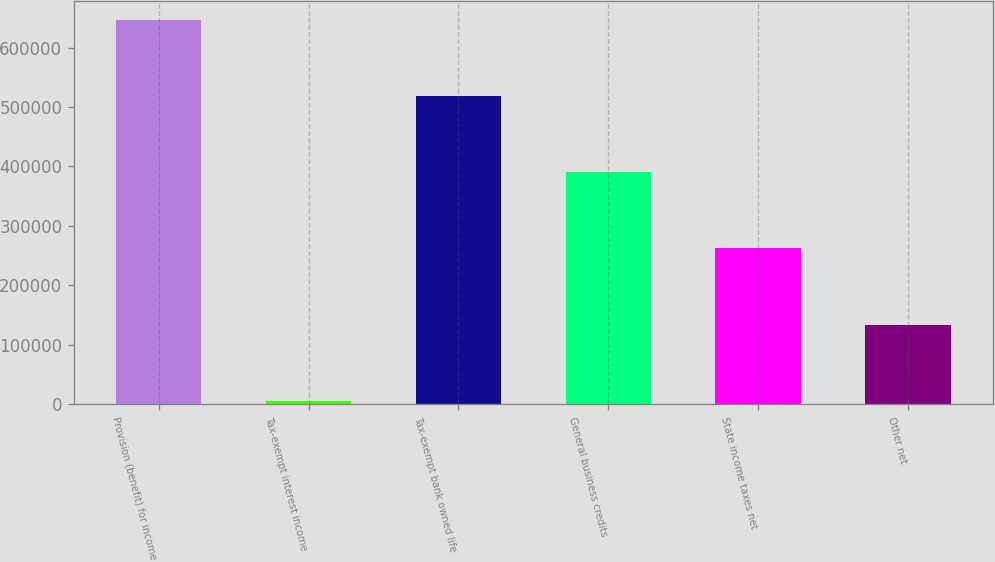<chart> <loc_0><loc_0><loc_500><loc_500><bar_chart><fcel>Provision (benefit) for income<fcel>Tax-exempt interest income<fcel>Tax-exempt bank owned life<fcel>General business credits<fcel>State income taxes net<fcel>Other net<nl><fcel>646462<fcel>5561<fcel>518282<fcel>390102<fcel>261922<fcel>133741<nl></chart> 